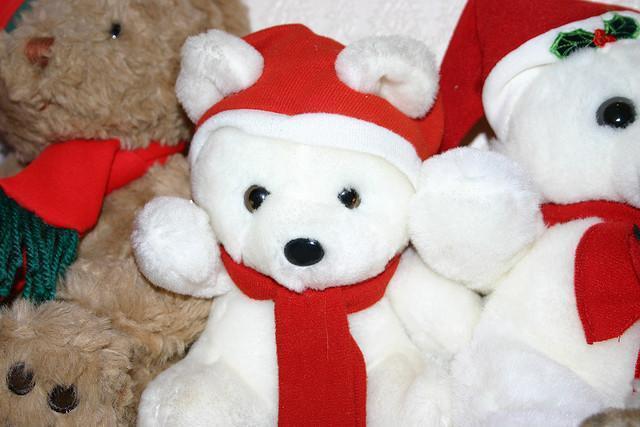How many white bears are in this scene?
Give a very brief answer. 2. How many white bears are there?
Give a very brief answer. 2. How many teddy bears can be seen?
Give a very brief answer. 3. 